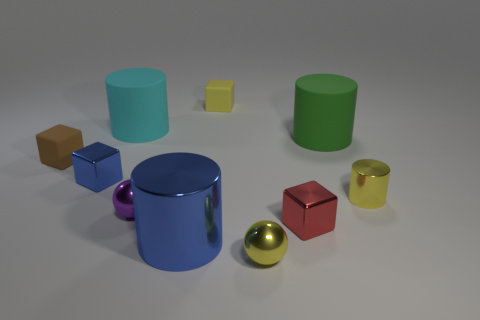Subtract 1 cubes. How many cubes are left? 3 Subtract all spheres. How many objects are left? 8 Subtract all small spheres. Subtract all small red metal things. How many objects are left? 7 Add 7 small metal spheres. How many small metal spheres are left? 9 Add 8 green matte cubes. How many green matte cubes exist? 8 Subtract 1 cyan cylinders. How many objects are left? 9 